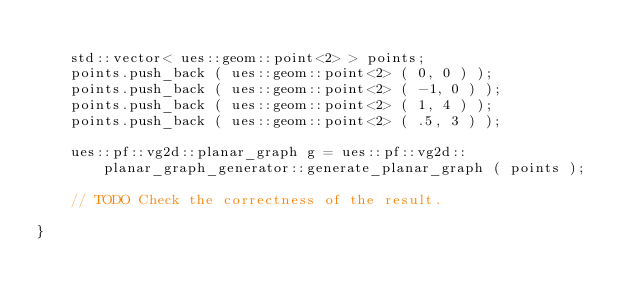<code> <loc_0><loc_0><loc_500><loc_500><_C_>
    std::vector< ues::geom::point<2> > points;
    points.push_back ( ues::geom::point<2> ( 0, 0 ) );
    points.push_back ( ues::geom::point<2> ( -1, 0 ) );
    points.push_back ( ues::geom::point<2> ( 1, 4 ) );
    points.push_back ( ues::geom::point<2> ( .5, 3 ) );

    ues::pf::vg2d::planar_graph g = ues::pf::vg2d::planar_graph_generator::generate_planar_graph ( points );

    // TODO Check the correctness of the result.

}
</code> 